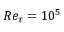Convert formula to latex. <formula><loc_0><loc_0><loc_500><loc_500>R e _ { \tau } = 1 0 ^ { 5 }</formula> 